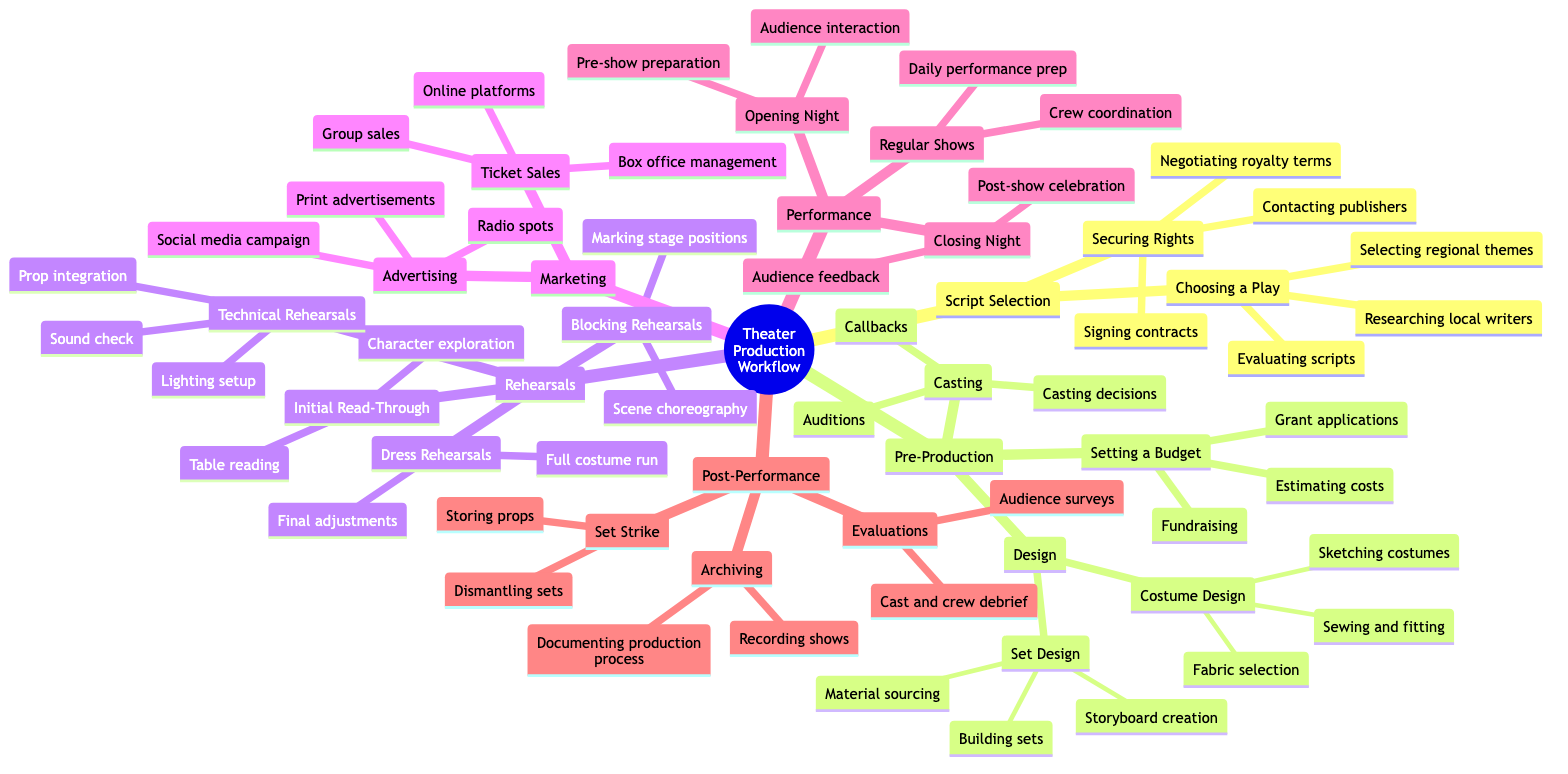What are the three key activities in Script Selection? The diagram lists three activities under Script Selection: Choosing a Play, which includes evaluating scripts, researching local writers, and selecting regional themes; and Securing Rights, which includes contacting publishers, negotiating royalty terms, and signing contracts.
Answer: Evaluating scripts, researching local writers, selecting regional themes How many main categories are shown in the Theater Production Workflow? The diagram outlines six main categories: Script Selection, Pre-Production, Rehearsals, Marketing, Performance, and Post-Performance. Therefore, to determine the total, I simply count these categories.
Answer: 6 What is the second step listed under Design in Pre-Production? Under the Design category, which is a sub-topic of Pre-Production, two areas are outlined: Set Design and Costume Design. Looking specifically at Costume Design, the second step is Fabric Selection.
Answer: Fabric selection What are the types of rehearsals listed in the Rehearsals category? In the Rehearsals category, there are four types mentioned: Initial Read-Through, Blocking Rehearsals, Technical Rehearsals, and Dress Rehearsals. To answer, I just list these items.
Answer: Initial Read-Through, Blocking Rehearsals, Technical Rehearsals, Dress Rehearsals Which activity involves Audience Feedback in the Performance section? Within the Performance category, the activity that includes Audience Feedback is during the Closing Night. By analyzing the flow and looking towards the final items listed, I find that "Audience feedback" appears under Closing Night.
Answer: Audience feedback What are the primary focuses of the Marketing category? The Marketing category comprises two main focuses: Advertising, which lists social media campaign, print advertisements, and radio spots; and Ticket Sales, which includes online platforms, box office management, and group sales. Hence, I'd summarize this by noting the two primary focuses within Marketing.
Answer: Advertising, Ticket Sales What is the last step listed under Post-Performance? In the Post-Performance section, there are three activities: Set Strike, Evaluations, and Archiving. The last step mentioned, which is the final activity in this section, is Documenting Production Process under Archiving.
Answer: Documenting Production Process How many steps are involved in Setting a Budget in Pre-Production? The Setting a Budget section has three steps listed: estimating costs, fundraising, and grant applications. Thus, I count them to find the total number of steps.
Answer: 3 